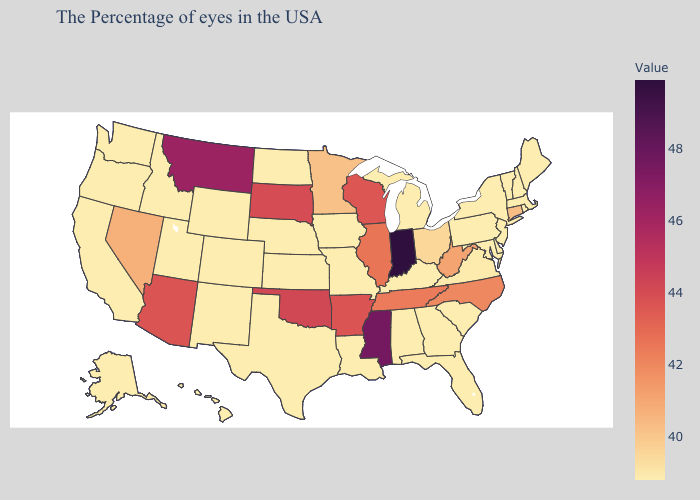Does Louisiana have the lowest value in the USA?
Concise answer only. Yes. Among the states that border Maine , which have the highest value?
Concise answer only. New Hampshire. Among the states that border Utah , which have the lowest value?
Answer briefly. Wyoming, Colorado, New Mexico, Idaho. Does Arkansas have the lowest value in the USA?
Quick response, please. No. 